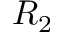<formula> <loc_0><loc_0><loc_500><loc_500>R _ { 2 }</formula> 